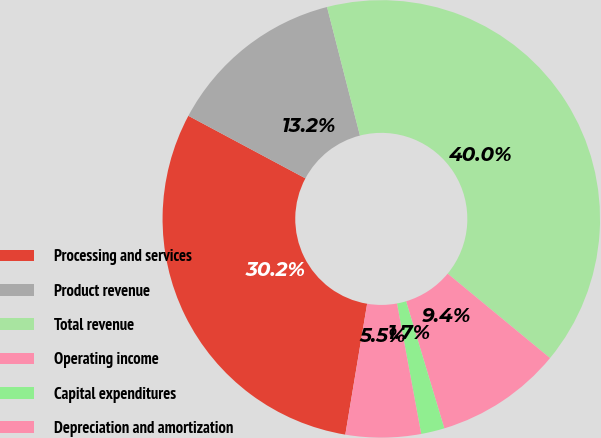Convert chart to OTSL. <chart><loc_0><loc_0><loc_500><loc_500><pie_chart><fcel>Processing and services<fcel>Product revenue<fcel>Total revenue<fcel>Operating income<fcel>Capital expenditures<fcel>Depreciation and amortization<nl><fcel>30.18%<fcel>13.2%<fcel>39.97%<fcel>9.37%<fcel>1.73%<fcel>5.55%<nl></chart> 